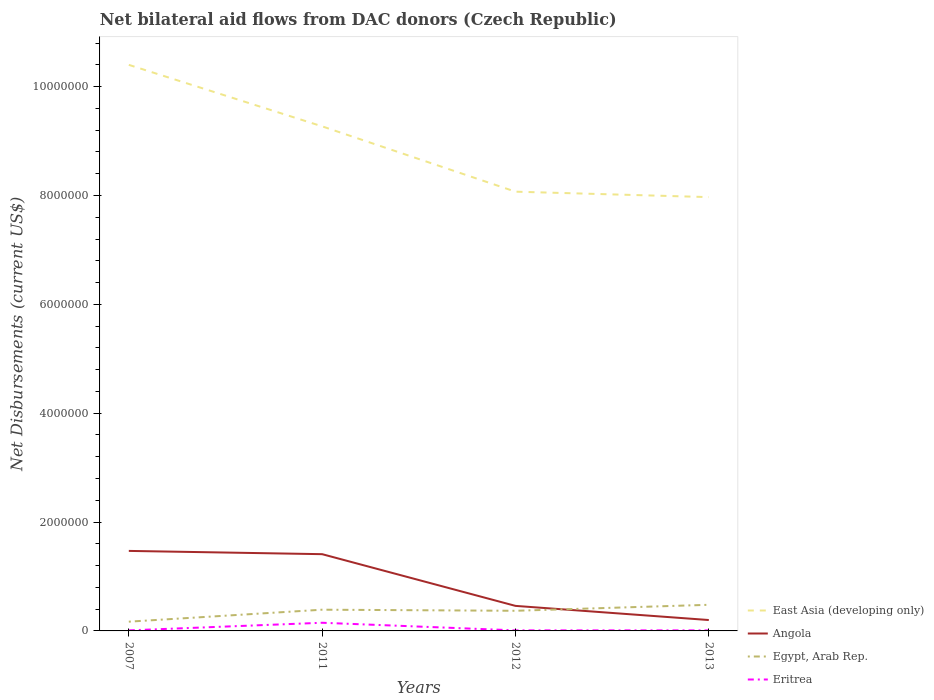How many different coloured lines are there?
Your answer should be compact. 4. Is the number of lines equal to the number of legend labels?
Your response must be concise. Yes. Across all years, what is the maximum net bilateral aid flows in East Asia (developing only)?
Your answer should be very brief. 7.97e+06. What is the total net bilateral aid flows in Eritrea in the graph?
Provide a succinct answer. 0. What is the difference between the highest and the second highest net bilateral aid flows in Angola?
Your answer should be compact. 1.27e+06. What is the difference between the highest and the lowest net bilateral aid flows in Egypt, Arab Rep.?
Offer a terse response. 3. Is the net bilateral aid flows in Angola strictly greater than the net bilateral aid flows in Eritrea over the years?
Give a very brief answer. No. How many years are there in the graph?
Ensure brevity in your answer.  4. What is the difference between two consecutive major ticks on the Y-axis?
Provide a succinct answer. 2.00e+06. Are the values on the major ticks of Y-axis written in scientific E-notation?
Keep it short and to the point. No. Does the graph contain any zero values?
Offer a very short reply. No. Does the graph contain grids?
Ensure brevity in your answer.  No. Where does the legend appear in the graph?
Keep it short and to the point. Bottom right. How many legend labels are there?
Provide a short and direct response. 4. What is the title of the graph?
Give a very brief answer. Net bilateral aid flows from DAC donors (Czech Republic). What is the label or title of the Y-axis?
Your response must be concise. Net Disbursements (current US$). What is the Net Disbursements (current US$) in East Asia (developing only) in 2007?
Offer a terse response. 1.04e+07. What is the Net Disbursements (current US$) in Angola in 2007?
Your response must be concise. 1.47e+06. What is the Net Disbursements (current US$) of East Asia (developing only) in 2011?
Your response must be concise. 9.27e+06. What is the Net Disbursements (current US$) of Angola in 2011?
Make the answer very short. 1.41e+06. What is the Net Disbursements (current US$) in Eritrea in 2011?
Give a very brief answer. 1.50e+05. What is the Net Disbursements (current US$) of East Asia (developing only) in 2012?
Your answer should be compact. 8.07e+06. What is the Net Disbursements (current US$) of Egypt, Arab Rep. in 2012?
Give a very brief answer. 3.70e+05. What is the Net Disbursements (current US$) in Eritrea in 2012?
Provide a short and direct response. 10000. What is the Net Disbursements (current US$) of East Asia (developing only) in 2013?
Give a very brief answer. 7.97e+06. What is the Net Disbursements (current US$) of Egypt, Arab Rep. in 2013?
Ensure brevity in your answer.  4.80e+05. Across all years, what is the maximum Net Disbursements (current US$) in East Asia (developing only)?
Provide a succinct answer. 1.04e+07. Across all years, what is the maximum Net Disbursements (current US$) in Angola?
Ensure brevity in your answer.  1.47e+06. Across all years, what is the maximum Net Disbursements (current US$) in Eritrea?
Your answer should be compact. 1.50e+05. Across all years, what is the minimum Net Disbursements (current US$) in East Asia (developing only)?
Provide a succinct answer. 7.97e+06. Across all years, what is the minimum Net Disbursements (current US$) in Angola?
Provide a short and direct response. 2.00e+05. Across all years, what is the minimum Net Disbursements (current US$) in Egypt, Arab Rep.?
Offer a terse response. 1.70e+05. What is the total Net Disbursements (current US$) in East Asia (developing only) in the graph?
Ensure brevity in your answer.  3.57e+07. What is the total Net Disbursements (current US$) of Angola in the graph?
Your answer should be very brief. 3.54e+06. What is the total Net Disbursements (current US$) in Egypt, Arab Rep. in the graph?
Your answer should be compact. 1.41e+06. What is the total Net Disbursements (current US$) in Eritrea in the graph?
Ensure brevity in your answer.  1.80e+05. What is the difference between the Net Disbursements (current US$) of East Asia (developing only) in 2007 and that in 2011?
Make the answer very short. 1.13e+06. What is the difference between the Net Disbursements (current US$) of Eritrea in 2007 and that in 2011?
Give a very brief answer. -1.40e+05. What is the difference between the Net Disbursements (current US$) in East Asia (developing only) in 2007 and that in 2012?
Provide a succinct answer. 2.33e+06. What is the difference between the Net Disbursements (current US$) of Angola in 2007 and that in 2012?
Make the answer very short. 1.01e+06. What is the difference between the Net Disbursements (current US$) of East Asia (developing only) in 2007 and that in 2013?
Provide a short and direct response. 2.43e+06. What is the difference between the Net Disbursements (current US$) of Angola in 2007 and that in 2013?
Give a very brief answer. 1.27e+06. What is the difference between the Net Disbursements (current US$) of Egypt, Arab Rep. in 2007 and that in 2013?
Give a very brief answer. -3.10e+05. What is the difference between the Net Disbursements (current US$) in East Asia (developing only) in 2011 and that in 2012?
Ensure brevity in your answer.  1.20e+06. What is the difference between the Net Disbursements (current US$) in Angola in 2011 and that in 2012?
Your answer should be very brief. 9.50e+05. What is the difference between the Net Disbursements (current US$) in Egypt, Arab Rep. in 2011 and that in 2012?
Offer a very short reply. 2.00e+04. What is the difference between the Net Disbursements (current US$) of East Asia (developing only) in 2011 and that in 2013?
Make the answer very short. 1.30e+06. What is the difference between the Net Disbursements (current US$) in Angola in 2011 and that in 2013?
Offer a very short reply. 1.21e+06. What is the difference between the Net Disbursements (current US$) in Eritrea in 2011 and that in 2013?
Your answer should be very brief. 1.40e+05. What is the difference between the Net Disbursements (current US$) in Angola in 2012 and that in 2013?
Offer a very short reply. 2.60e+05. What is the difference between the Net Disbursements (current US$) in East Asia (developing only) in 2007 and the Net Disbursements (current US$) in Angola in 2011?
Your response must be concise. 8.99e+06. What is the difference between the Net Disbursements (current US$) in East Asia (developing only) in 2007 and the Net Disbursements (current US$) in Egypt, Arab Rep. in 2011?
Keep it short and to the point. 1.00e+07. What is the difference between the Net Disbursements (current US$) in East Asia (developing only) in 2007 and the Net Disbursements (current US$) in Eritrea in 2011?
Offer a terse response. 1.02e+07. What is the difference between the Net Disbursements (current US$) of Angola in 2007 and the Net Disbursements (current US$) of Egypt, Arab Rep. in 2011?
Your answer should be very brief. 1.08e+06. What is the difference between the Net Disbursements (current US$) of Angola in 2007 and the Net Disbursements (current US$) of Eritrea in 2011?
Make the answer very short. 1.32e+06. What is the difference between the Net Disbursements (current US$) of East Asia (developing only) in 2007 and the Net Disbursements (current US$) of Angola in 2012?
Keep it short and to the point. 9.94e+06. What is the difference between the Net Disbursements (current US$) in East Asia (developing only) in 2007 and the Net Disbursements (current US$) in Egypt, Arab Rep. in 2012?
Keep it short and to the point. 1.00e+07. What is the difference between the Net Disbursements (current US$) of East Asia (developing only) in 2007 and the Net Disbursements (current US$) of Eritrea in 2012?
Offer a very short reply. 1.04e+07. What is the difference between the Net Disbursements (current US$) in Angola in 2007 and the Net Disbursements (current US$) in Egypt, Arab Rep. in 2012?
Provide a succinct answer. 1.10e+06. What is the difference between the Net Disbursements (current US$) in Angola in 2007 and the Net Disbursements (current US$) in Eritrea in 2012?
Provide a short and direct response. 1.46e+06. What is the difference between the Net Disbursements (current US$) in Egypt, Arab Rep. in 2007 and the Net Disbursements (current US$) in Eritrea in 2012?
Offer a very short reply. 1.60e+05. What is the difference between the Net Disbursements (current US$) in East Asia (developing only) in 2007 and the Net Disbursements (current US$) in Angola in 2013?
Provide a short and direct response. 1.02e+07. What is the difference between the Net Disbursements (current US$) of East Asia (developing only) in 2007 and the Net Disbursements (current US$) of Egypt, Arab Rep. in 2013?
Your response must be concise. 9.92e+06. What is the difference between the Net Disbursements (current US$) of East Asia (developing only) in 2007 and the Net Disbursements (current US$) of Eritrea in 2013?
Provide a short and direct response. 1.04e+07. What is the difference between the Net Disbursements (current US$) of Angola in 2007 and the Net Disbursements (current US$) of Egypt, Arab Rep. in 2013?
Provide a succinct answer. 9.90e+05. What is the difference between the Net Disbursements (current US$) of Angola in 2007 and the Net Disbursements (current US$) of Eritrea in 2013?
Your answer should be very brief. 1.46e+06. What is the difference between the Net Disbursements (current US$) of East Asia (developing only) in 2011 and the Net Disbursements (current US$) of Angola in 2012?
Your response must be concise. 8.81e+06. What is the difference between the Net Disbursements (current US$) of East Asia (developing only) in 2011 and the Net Disbursements (current US$) of Egypt, Arab Rep. in 2012?
Your answer should be compact. 8.90e+06. What is the difference between the Net Disbursements (current US$) of East Asia (developing only) in 2011 and the Net Disbursements (current US$) of Eritrea in 2012?
Ensure brevity in your answer.  9.26e+06. What is the difference between the Net Disbursements (current US$) in Angola in 2011 and the Net Disbursements (current US$) in Egypt, Arab Rep. in 2012?
Your response must be concise. 1.04e+06. What is the difference between the Net Disbursements (current US$) of Angola in 2011 and the Net Disbursements (current US$) of Eritrea in 2012?
Provide a short and direct response. 1.40e+06. What is the difference between the Net Disbursements (current US$) in East Asia (developing only) in 2011 and the Net Disbursements (current US$) in Angola in 2013?
Your response must be concise. 9.07e+06. What is the difference between the Net Disbursements (current US$) of East Asia (developing only) in 2011 and the Net Disbursements (current US$) of Egypt, Arab Rep. in 2013?
Offer a terse response. 8.79e+06. What is the difference between the Net Disbursements (current US$) of East Asia (developing only) in 2011 and the Net Disbursements (current US$) of Eritrea in 2013?
Provide a short and direct response. 9.26e+06. What is the difference between the Net Disbursements (current US$) in Angola in 2011 and the Net Disbursements (current US$) in Egypt, Arab Rep. in 2013?
Keep it short and to the point. 9.30e+05. What is the difference between the Net Disbursements (current US$) in Angola in 2011 and the Net Disbursements (current US$) in Eritrea in 2013?
Your answer should be compact. 1.40e+06. What is the difference between the Net Disbursements (current US$) in East Asia (developing only) in 2012 and the Net Disbursements (current US$) in Angola in 2013?
Keep it short and to the point. 7.87e+06. What is the difference between the Net Disbursements (current US$) in East Asia (developing only) in 2012 and the Net Disbursements (current US$) in Egypt, Arab Rep. in 2013?
Make the answer very short. 7.59e+06. What is the difference between the Net Disbursements (current US$) in East Asia (developing only) in 2012 and the Net Disbursements (current US$) in Eritrea in 2013?
Keep it short and to the point. 8.06e+06. What is the average Net Disbursements (current US$) in East Asia (developing only) per year?
Provide a succinct answer. 8.93e+06. What is the average Net Disbursements (current US$) in Angola per year?
Keep it short and to the point. 8.85e+05. What is the average Net Disbursements (current US$) of Egypt, Arab Rep. per year?
Offer a very short reply. 3.52e+05. What is the average Net Disbursements (current US$) in Eritrea per year?
Provide a succinct answer. 4.50e+04. In the year 2007, what is the difference between the Net Disbursements (current US$) in East Asia (developing only) and Net Disbursements (current US$) in Angola?
Offer a terse response. 8.93e+06. In the year 2007, what is the difference between the Net Disbursements (current US$) in East Asia (developing only) and Net Disbursements (current US$) in Egypt, Arab Rep.?
Provide a succinct answer. 1.02e+07. In the year 2007, what is the difference between the Net Disbursements (current US$) of East Asia (developing only) and Net Disbursements (current US$) of Eritrea?
Your response must be concise. 1.04e+07. In the year 2007, what is the difference between the Net Disbursements (current US$) in Angola and Net Disbursements (current US$) in Egypt, Arab Rep.?
Your answer should be very brief. 1.30e+06. In the year 2007, what is the difference between the Net Disbursements (current US$) of Angola and Net Disbursements (current US$) of Eritrea?
Keep it short and to the point. 1.46e+06. In the year 2007, what is the difference between the Net Disbursements (current US$) of Egypt, Arab Rep. and Net Disbursements (current US$) of Eritrea?
Your answer should be compact. 1.60e+05. In the year 2011, what is the difference between the Net Disbursements (current US$) of East Asia (developing only) and Net Disbursements (current US$) of Angola?
Your answer should be compact. 7.86e+06. In the year 2011, what is the difference between the Net Disbursements (current US$) in East Asia (developing only) and Net Disbursements (current US$) in Egypt, Arab Rep.?
Provide a succinct answer. 8.88e+06. In the year 2011, what is the difference between the Net Disbursements (current US$) of East Asia (developing only) and Net Disbursements (current US$) of Eritrea?
Your answer should be very brief. 9.12e+06. In the year 2011, what is the difference between the Net Disbursements (current US$) of Angola and Net Disbursements (current US$) of Egypt, Arab Rep.?
Ensure brevity in your answer.  1.02e+06. In the year 2011, what is the difference between the Net Disbursements (current US$) in Angola and Net Disbursements (current US$) in Eritrea?
Your answer should be compact. 1.26e+06. In the year 2012, what is the difference between the Net Disbursements (current US$) in East Asia (developing only) and Net Disbursements (current US$) in Angola?
Your answer should be compact. 7.61e+06. In the year 2012, what is the difference between the Net Disbursements (current US$) in East Asia (developing only) and Net Disbursements (current US$) in Egypt, Arab Rep.?
Your response must be concise. 7.70e+06. In the year 2012, what is the difference between the Net Disbursements (current US$) in East Asia (developing only) and Net Disbursements (current US$) in Eritrea?
Your response must be concise. 8.06e+06. In the year 2012, what is the difference between the Net Disbursements (current US$) in Angola and Net Disbursements (current US$) in Eritrea?
Offer a terse response. 4.50e+05. In the year 2013, what is the difference between the Net Disbursements (current US$) of East Asia (developing only) and Net Disbursements (current US$) of Angola?
Your answer should be very brief. 7.77e+06. In the year 2013, what is the difference between the Net Disbursements (current US$) in East Asia (developing only) and Net Disbursements (current US$) in Egypt, Arab Rep.?
Keep it short and to the point. 7.49e+06. In the year 2013, what is the difference between the Net Disbursements (current US$) of East Asia (developing only) and Net Disbursements (current US$) of Eritrea?
Your response must be concise. 7.96e+06. In the year 2013, what is the difference between the Net Disbursements (current US$) of Angola and Net Disbursements (current US$) of Egypt, Arab Rep.?
Give a very brief answer. -2.80e+05. What is the ratio of the Net Disbursements (current US$) in East Asia (developing only) in 2007 to that in 2011?
Make the answer very short. 1.12. What is the ratio of the Net Disbursements (current US$) in Angola in 2007 to that in 2011?
Your answer should be very brief. 1.04. What is the ratio of the Net Disbursements (current US$) of Egypt, Arab Rep. in 2007 to that in 2011?
Offer a terse response. 0.44. What is the ratio of the Net Disbursements (current US$) in Eritrea in 2007 to that in 2011?
Provide a short and direct response. 0.07. What is the ratio of the Net Disbursements (current US$) in East Asia (developing only) in 2007 to that in 2012?
Your answer should be compact. 1.29. What is the ratio of the Net Disbursements (current US$) of Angola in 2007 to that in 2012?
Offer a very short reply. 3.2. What is the ratio of the Net Disbursements (current US$) of Egypt, Arab Rep. in 2007 to that in 2012?
Offer a terse response. 0.46. What is the ratio of the Net Disbursements (current US$) in East Asia (developing only) in 2007 to that in 2013?
Offer a terse response. 1.3. What is the ratio of the Net Disbursements (current US$) of Angola in 2007 to that in 2013?
Offer a terse response. 7.35. What is the ratio of the Net Disbursements (current US$) of Egypt, Arab Rep. in 2007 to that in 2013?
Make the answer very short. 0.35. What is the ratio of the Net Disbursements (current US$) of East Asia (developing only) in 2011 to that in 2012?
Your response must be concise. 1.15. What is the ratio of the Net Disbursements (current US$) in Angola in 2011 to that in 2012?
Keep it short and to the point. 3.07. What is the ratio of the Net Disbursements (current US$) in Egypt, Arab Rep. in 2011 to that in 2012?
Ensure brevity in your answer.  1.05. What is the ratio of the Net Disbursements (current US$) in Eritrea in 2011 to that in 2012?
Ensure brevity in your answer.  15. What is the ratio of the Net Disbursements (current US$) in East Asia (developing only) in 2011 to that in 2013?
Your response must be concise. 1.16. What is the ratio of the Net Disbursements (current US$) of Angola in 2011 to that in 2013?
Keep it short and to the point. 7.05. What is the ratio of the Net Disbursements (current US$) in Egypt, Arab Rep. in 2011 to that in 2013?
Provide a short and direct response. 0.81. What is the ratio of the Net Disbursements (current US$) in Eritrea in 2011 to that in 2013?
Offer a terse response. 15. What is the ratio of the Net Disbursements (current US$) in East Asia (developing only) in 2012 to that in 2013?
Make the answer very short. 1.01. What is the ratio of the Net Disbursements (current US$) of Egypt, Arab Rep. in 2012 to that in 2013?
Offer a terse response. 0.77. What is the ratio of the Net Disbursements (current US$) of Eritrea in 2012 to that in 2013?
Provide a succinct answer. 1. What is the difference between the highest and the second highest Net Disbursements (current US$) in East Asia (developing only)?
Offer a terse response. 1.13e+06. What is the difference between the highest and the lowest Net Disbursements (current US$) of East Asia (developing only)?
Ensure brevity in your answer.  2.43e+06. What is the difference between the highest and the lowest Net Disbursements (current US$) of Angola?
Your answer should be compact. 1.27e+06. What is the difference between the highest and the lowest Net Disbursements (current US$) in Eritrea?
Make the answer very short. 1.40e+05. 